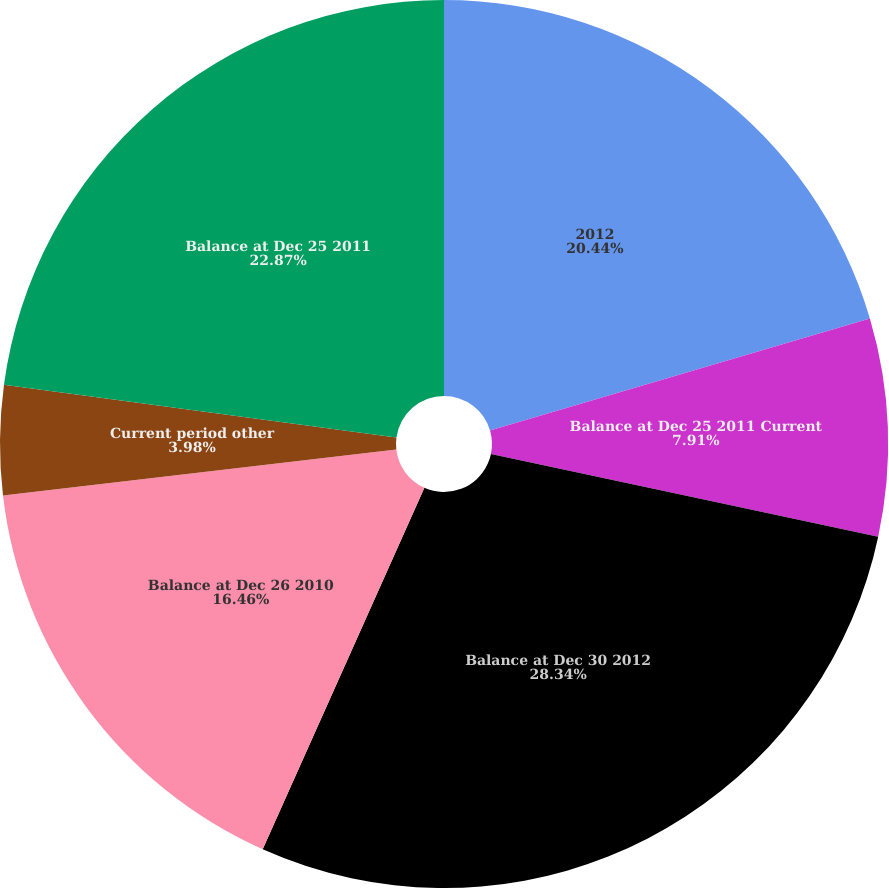<chart> <loc_0><loc_0><loc_500><loc_500><pie_chart><fcel>2012<fcel>Balance at Dec 25 2011 Current<fcel>Balance at Dec 30 2012<fcel>Balance at Dec 26 2010<fcel>Current period other<fcel>Balance at Dec 25 2011<nl><fcel>20.44%<fcel>7.91%<fcel>28.35%<fcel>16.46%<fcel>3.98%<fcel>22.87%<nl></chart> 